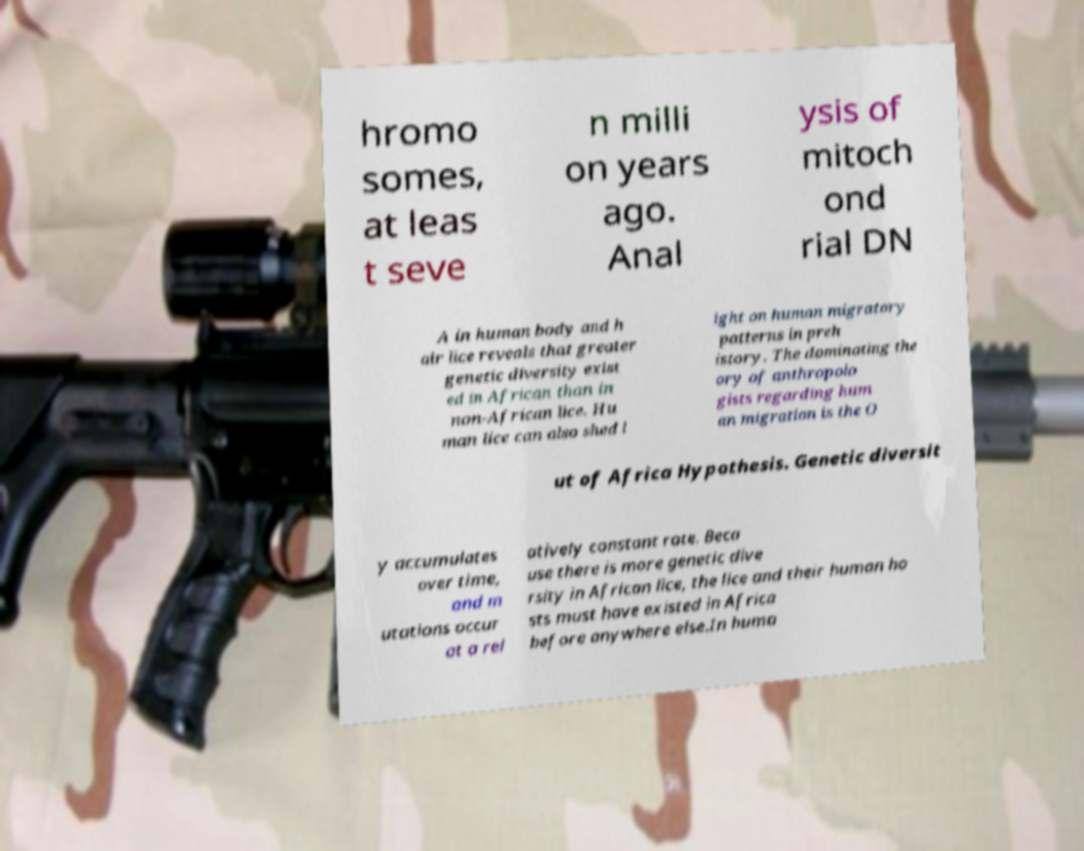Could you extract and type out the text from this image? hromo somes, at leas t seve n milli on years ago. Anal ysis of mitoch ond rial DN A in human body and h air lice reveals that greater genetic diversity exist ed in African than in non-African lice. Hu man lice can also shed l ight on human migratory patterns in preh istory. The dominating the ory of anthropolo gists regarding hum an migration is the O ut of Africa Hypothesis. Genetic diversit y accumulates over time, and m utations occur at a rel atively constant rate. Beca use there is more genetic dive rsity in African lice, the lice and their human ho sts must have existed in Africa before anywhere else.In huma 